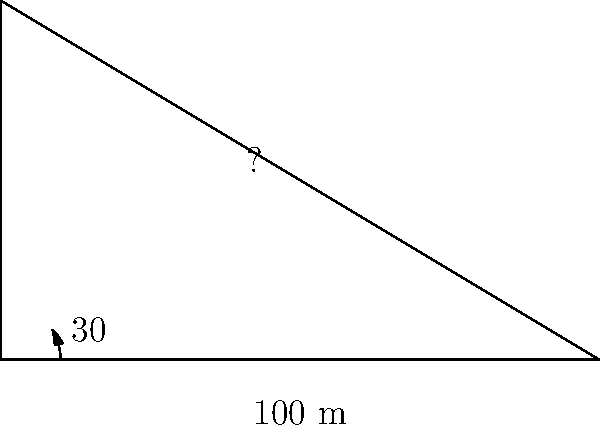At the Holmenkollen Ski Jump in Oslo, you're designing a new ski jump ramp. The horizontal distance from the start of the ramp to the take-off point is 100 meters, and the ramp forms a 30° angle with the horizontal. What is the length of the ski jump ramp? Let's approach this step-by-step using trigonometry:

1) We can treat the ski jump ramp as the hypotenuse of a right-angled triangle.

2) We know:
   - The angle of inclination: $\theta = 30°$
   - The adjacent side (horizontal distance): $a = 100$ meters

3) We need to find the hypotenuse (length of the ramp). Let's call this $h$.

4) In a right-angled triangle, we can use the cosine function:

   $\cos \theta = \frac{\text{adjacent}}{\text{hypotenuse}}$

5) Substituting our known values:

   $\cos 30° = \frac{100}{h}$

6) We know that $\cos 30° = \frac{\sqrt{3}}{2}$. So:

   $\frac{\sqrt{3}}{2} = \frac{100}{h}$

7) Cross multiply:

   $h \cdot \frac{\sqrt{3}}{2} = 100$

8) Solve for $h$:

   $h = \frac{100}{\frac{\sqrt{3}}{2}} = \frac{200}{\sqrt{3}}$

9) Simplify:

   $h = \frac{200}{\sqrt{3}} \cdot \frac{\sqrt{3}}{\sqrt{3}} = \frac{200\sqrt{3}}{3} \approx 115.47$ meters

Therefore, the length of the ski jump ramp is approximately 115.47 meters.
Answer: $\frac{200\sqrt{3}}{3}$ meters (or approximately 115.47 meters) 